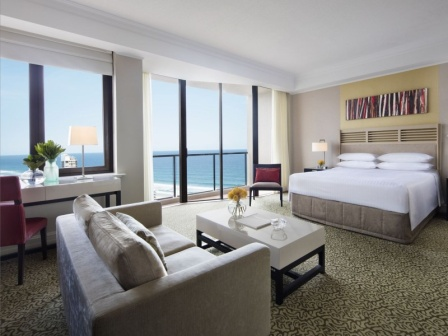What time of day does it appear to be based on the lighting in the image? The bright natural light and visible blue sky suggest it's midday. The room is bathed in daylight, indicating sunshine and clear weather outside, typical of a sunny midday atmosphere. 